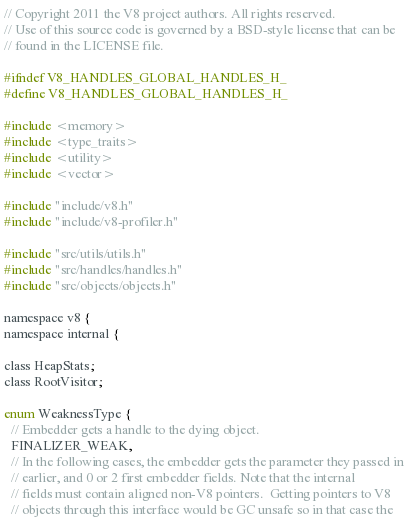<code> <loc_0><loc_0><loc_500><loc_500><_C_>// Copyright 2011 the V8 project authors. All rights reserved.
// Use of this source code is governed by a BSD-style license that can be
// found in the LICENSE file.

#ifndef V8_HANDLES_GLOBAL_HANDLES_H_
#define V8_HANDLES_GLOBAL_HANDLES_H_

#include <memory>
#include <type_traits>
#include <utility>
#include <vector>

#include "include/v8.h"
#include "include/v8-profiler.h"

#include "src/utils/utils.h"
#include "src/handles/handles.h"
#include "src/objects/objects.h"

namespace v8 {
namespace internal {

class HeapStats;
class RootVisitor;

enum WeaknessType {
  // Embedder gets a handle to the dying object.
  FINALIZER_WEAK,
  // In the following cases, the embedder gets the parameter they passed in
  // earlier, and 0 or 2 first embedder fields. Note that the internal
  // fields must contain aligned non-V8 pointers.  Getting pointers to V8
  // objects through this interface would be GC unsafe so in that case the</code> 